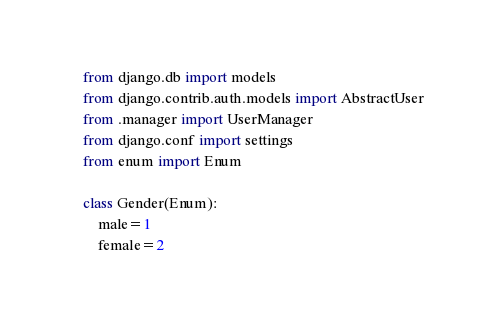<code> <loc_0><loc_0><loc_500><loc_500><_Python_>from django.db import models
from django.contrib.auth.models import AbstractUser
from .manager import UserManager
from django.conf import settings
from enum import Enum

class Gender(Enum):
    male=1
    female=2</code> 